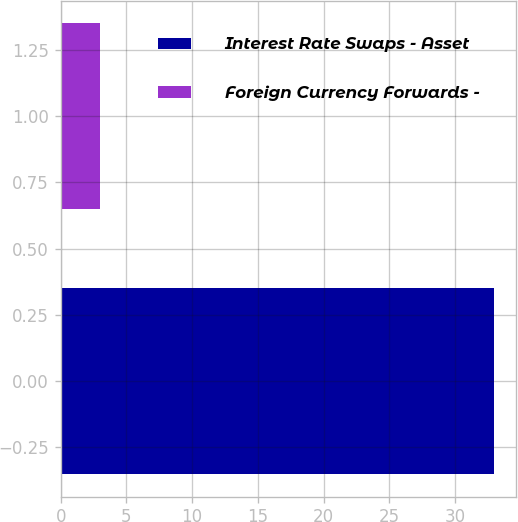Convert chart. <chart><loc_0><loc_0><loc_500><loc_500><bar_chart><fcel>Interest Rate Swaps - Asset<fcel>Foreign Currency Forwards -<nl><fcel>33<fcel>3<nl></chart> 